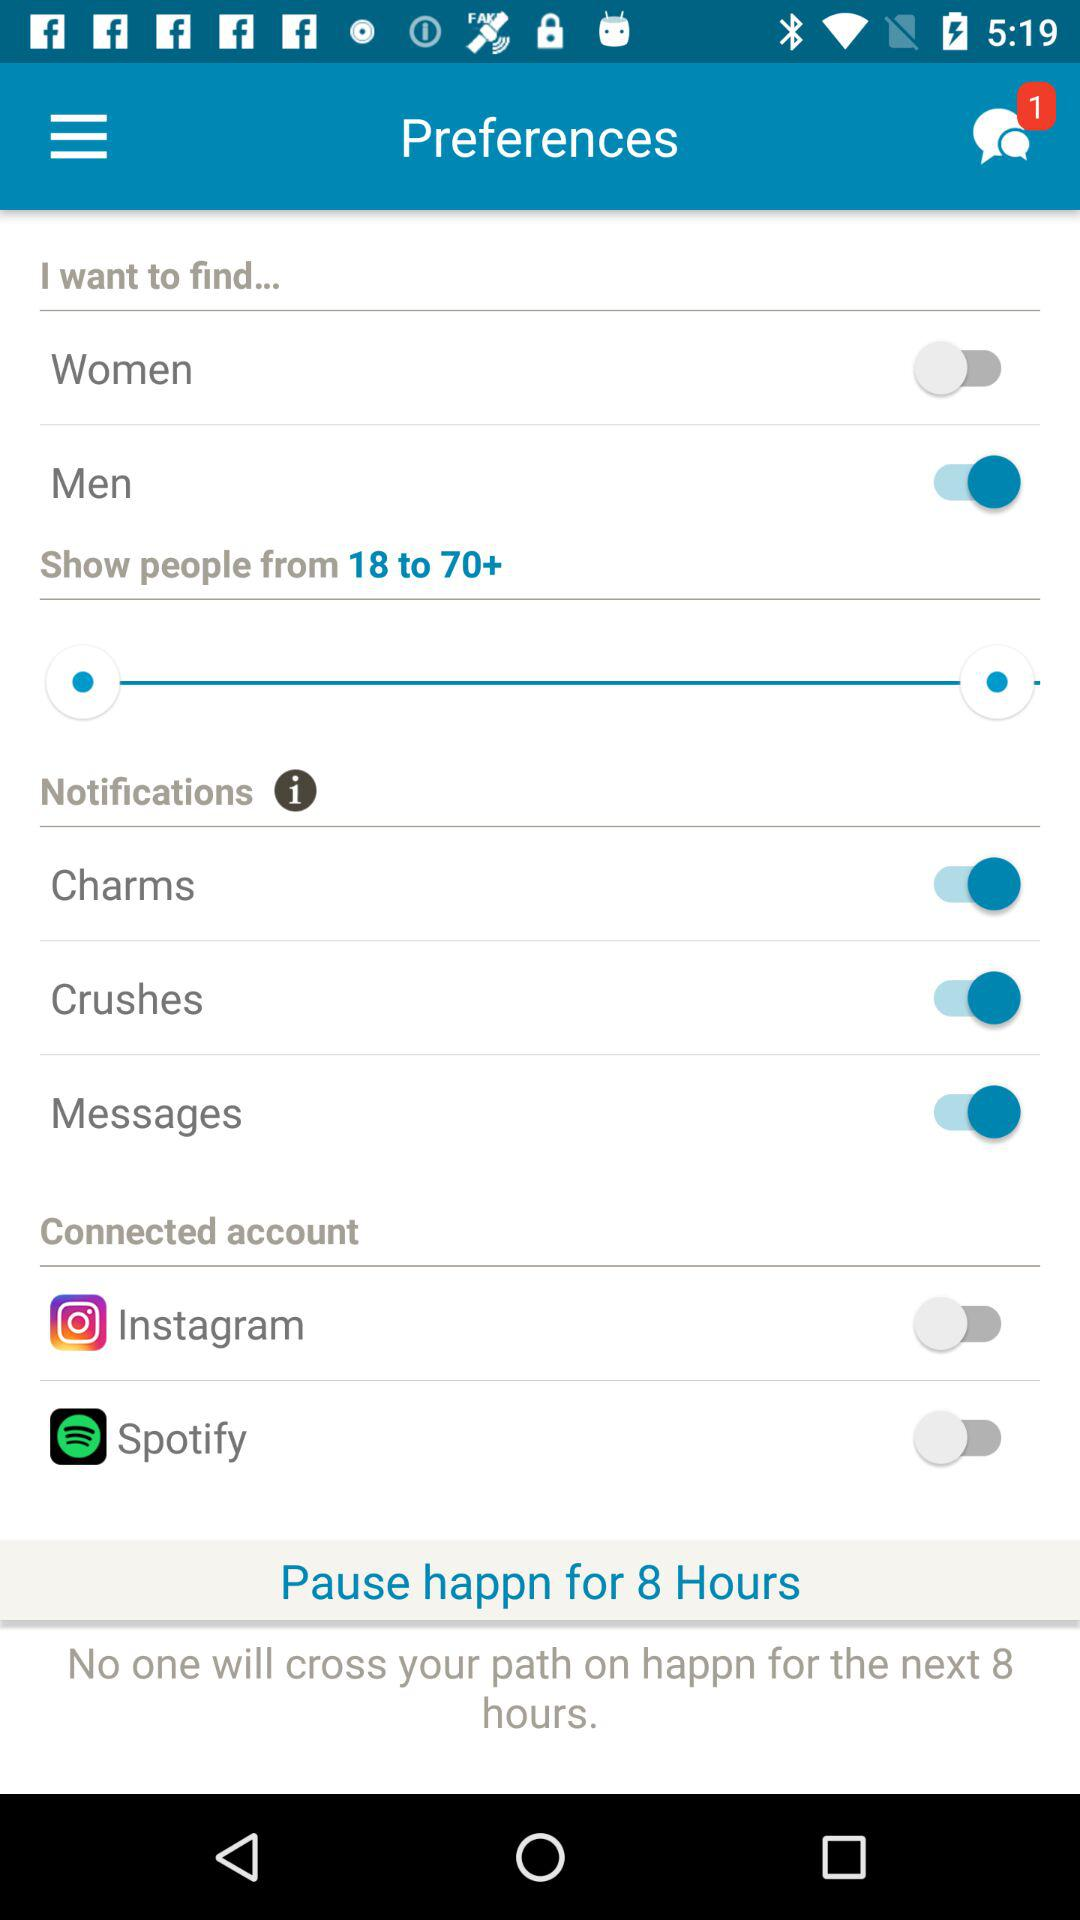What is the status of crushes? The status is "on". 